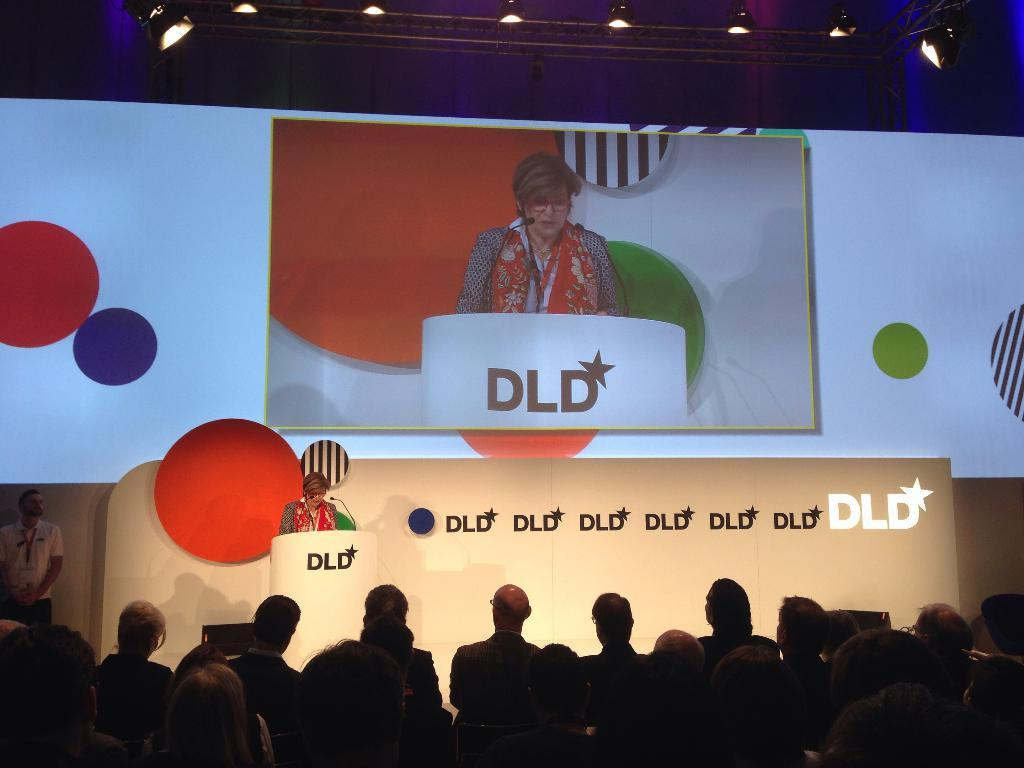What is happening at the bottom of the image? There are people standing at the bottom of the image. What can be seen in the background of the image? There is a screen in the background of the image. Can you describe the lady's position in the image? There is a lady standing near a podium in the center of the image. What type of pest can be seen crawling on the screen in the image? There is no pest visible on the screen in the image. What season is it during the event in the image? The provided facts do not mention any event or season, so it cannot be determined from the image. 